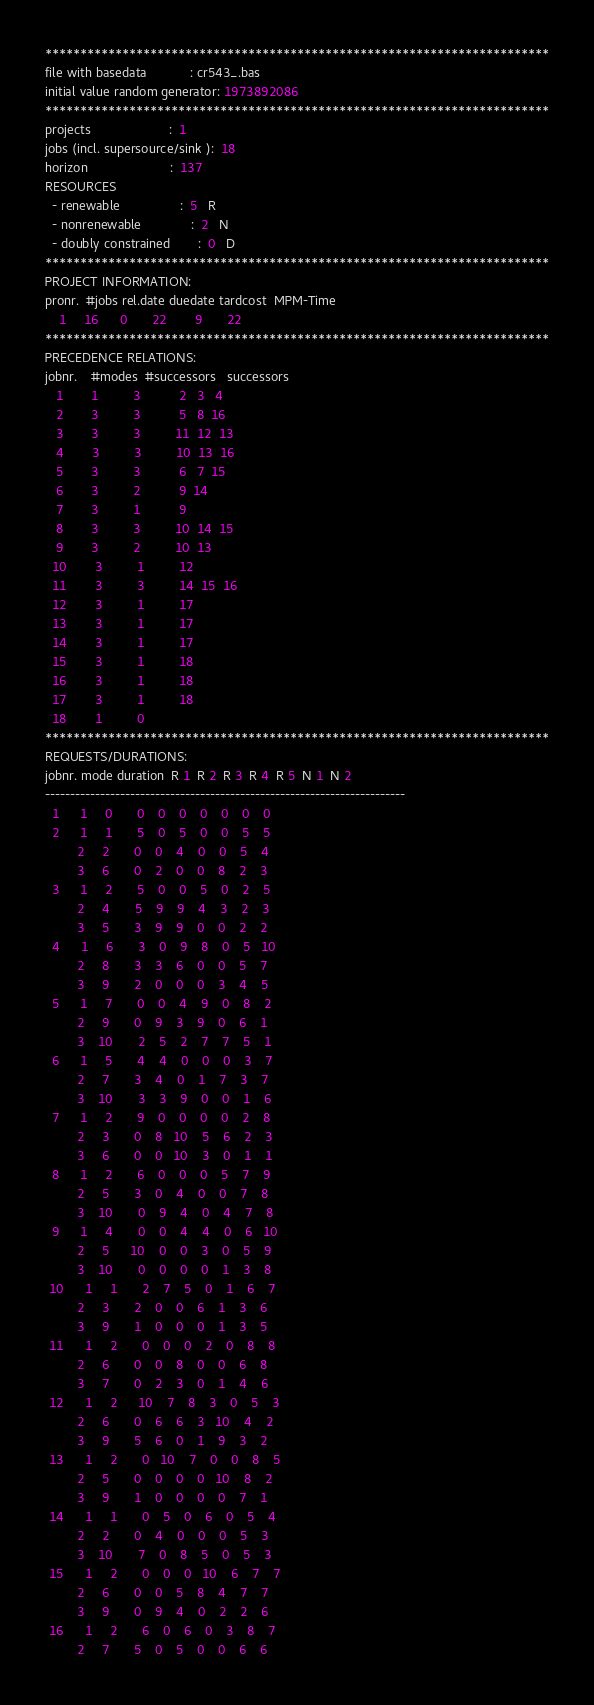<code> <loc_0><loc_0><loc_500><loc_500><_ObjectiveC_>************************************************************************
file with basedata            : cr543_.bas
initial value random generator: 1973892086
************************************************************************
projects                      :  1
jobs (incl. supersource/sink ):  18
horizon                       :  137
RESOURCES
  - renewable                 :  5   R
  - nonrenewable              :  2   N
  - doubly constrained        :  0   D
************************************************************************
PROJECT INFORMATION:
pronr.  #jobs rel.date duedate tardcost  MPM-Time
    1     16      0       22        9       22
************************************************************************
PRECEDENCE RELATIONS:
jobnr.    #modes  #successors   successors
   1        1          3           2   3   4
   2        3          3           5   8  16
   3        3          3          11  12  13
   4        3          3          10  13  16
   5        3          3           6   7  15
   6        3          2           9  14
   7        3          1           9
   8        3          3          10  14  15
   9        3          2          10  13
  10        3          1          12
  11        3          3          14  15  16
  12        3          1          17
  13        3          1          17
  14        3          1          17
  15        3          1          18
  16        3          1          18
  17        3          1          18
  18        1          0        
************************************************************************
REQUESTS/DURATIONS:
jobnr. mode duration  R 1  R 2  R 3  R 4  R 5  N 1  N 2
------------------------------------------------------------------------
  1      1     0       0    0    0    0    0    0    0
  2      1     1       5    0    5    0    0    5    5
         2     2       0    0    4    0    0    5    4
         3     6       0    2    0    0    8    2    3
  3      1     2       5    0    0    5    0    2    5
         2     4       5    9    9    4    3    2    3
         3     5       3    9    9    0    0    2    2
  4      1     6       3    0    9    8    0    5   10
         2     8       3    3    6    0    0    5    7
         3     9       2    0    0    0    3    4    5
  5      1     7       0    0    4    9    0    8    2
         2     9       0    9    3    9    0    6    1
         3    10       2    5    2    7    7    5    1
  6      1     5       4    4    0    0    0    3    7
         2     7       3    4    0    1    7    3    7
         3    10       3    3    9    0    0    1    6
  7      1     2       9    0    0    0    0    2    8
         2     3       0    8   10    5    6    2    3
         3     6       0    0   10    3    0    1    1
  8      1     2       6    0    0    0    5    7    9
         2     5       3    0    4    0    0    7    8
         3    10       0    9    4    0    4    7    8
  9      1     4       0    0    4    4    0    6   10
         2     5      10    0    0    3    0    5    9
         3    10       0    0    0    0    1    3    8
 10      1     1       2    7    5    0    1    6    7
         2     3       2    0    0    6    1    3    6
         3     9       1    0    0    0    1    3    5
 11      1     2       0    0    0    2    0    8    8
         2     6       0    0    8    0    0    6    8
         3     7       0    2    3    0    1    4    6
 12      1     2      10    7    8    3    0    5    3
         2     6       0    6    6    3   10    4    2
         3     9       5    6    0    1    9    3    2
 13      1     2       0   10    7    0    0    8    5
         2     5       0    0    0    0   10    8    2
         3     9       1    0    0    0    0    7    1
 14      1     1       0    5    0    6    0    5    4
         2     2       0    4    0    0    0    5    3
         3    10       7    0    8    5    0    5    3
 15      1     2       0    0    0   10    6    7    7
         2     6       0    0    5    8    4    7    7
         3     9       0    9    4    0    2    2    6
 16      1     2       6    0    6    0    3    8    7
         2     7       5    0    5    0    0    6    6</code> 